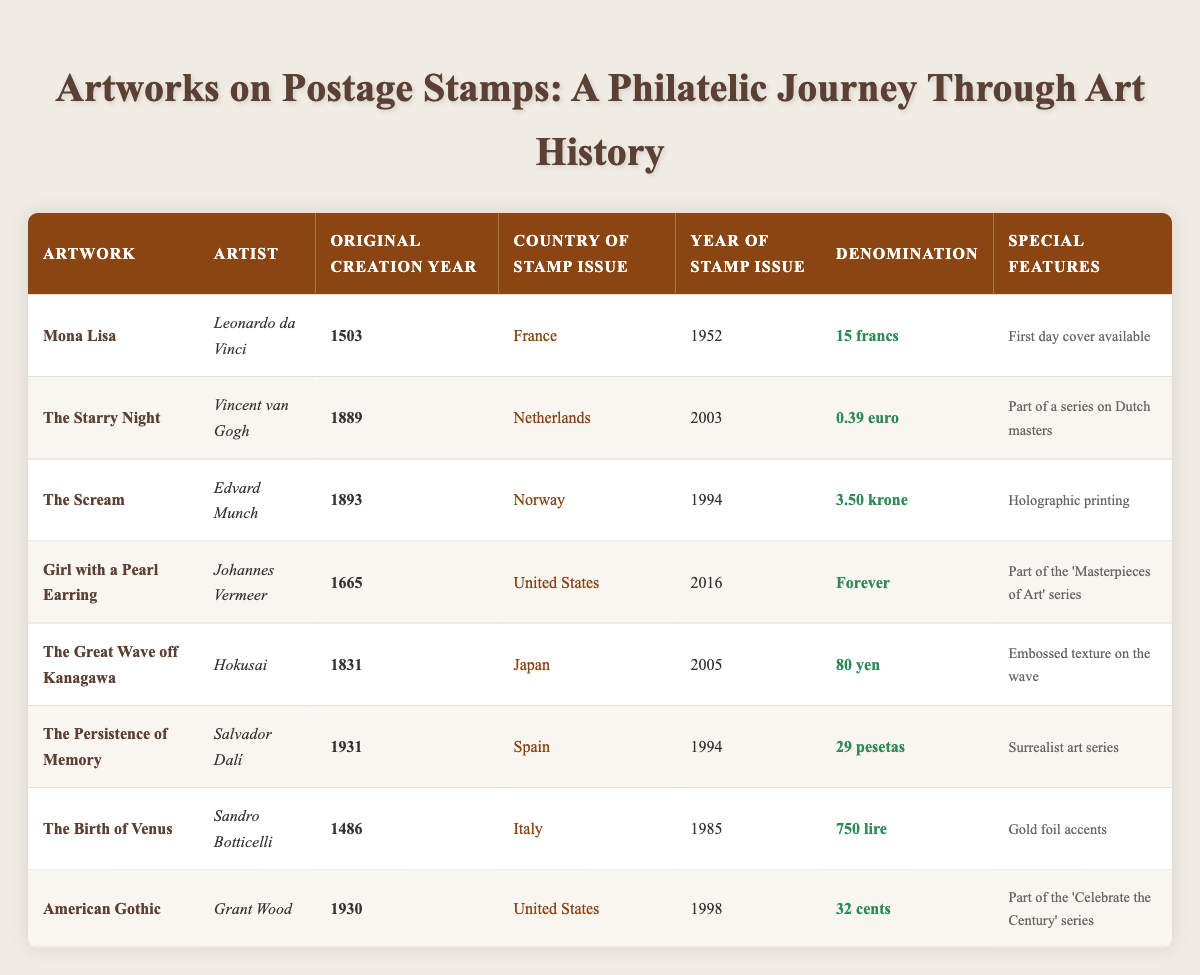What is the original creation year of "The Starry Night"? The original creation year for "The Starry Night" is listed in the table under the "Original Creation Year" column, which shows it as 1889.
Answer: 1889 Which artwork was issued as a stamp first, "The Birth of Venus" or "The Great Wave off Kanagawa"? By comparing the "Year of Stamp Issue" for both artworks, "The Birth of Venus" was issued in 1985 and "The Great Wave off Kanagawa" was issued in 2005. Therefore, "The Birth of Venus" was issued earlier.
Answer: "The Birth of Venus" Which country issued the most recent stamp featuring artwork from this table? The most recent year of stamp issue from the table is 2016 for "Girl with a Pearl Earring," issued by the United States, making it the most recent.
Answer: United States Did any artwork from the table feature special printing techniques? Yes, the table indicates that "The Scream" utilized holographic printing and "The Great Wave off Kanagawa" had an embossed texture on the wave.
Answer: Yes What is the total denomination value of all stamps from the United States? The denominations for the U.S. artworks are "Forever" (treated as 1), "32 cents" (0.32), and since denominations cannot be summed directly across different units, the value is "Forever," but in cents, the total is 0.32.
Answer: 0.32 (in cents) Which artist has the earliest original creation date? Comparing all the original creation years, "The Birth of Venus" by Sandro Botticelli has the earliest date at 1486, which is before all other artworks listed.
Answer: Sandro Botticelli What common feature do both "Girl with a Pearl Earring" and "American Gothic" share in terms of their stamp series? Both "Girl with a Pearl Earring" and "American Gothic" are part of series: "Girl with a Pearl Earring" is part of the "Masterpieces of Art" series and "American Gothic" is part of the "Celebrate the Century" series, showcasing their significance.
Answer: Both are part of special series Which artwork has been recognized with gold foil accents on its stamp? The artwork "The Birth of Venus" is noted in the table for having gold foil accents on its stamp, which signifies a premium design feature.
Answer: The Birth of Venus 